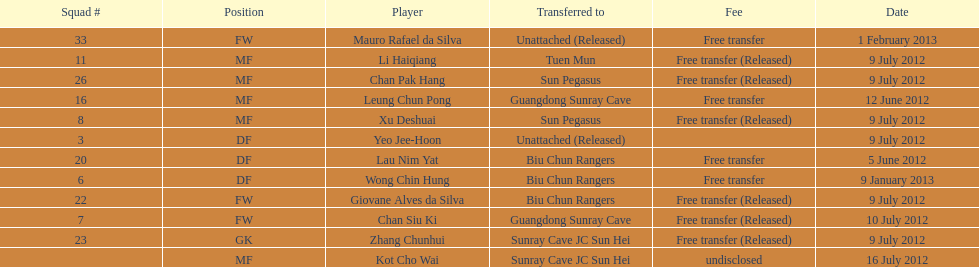Player transferred immediately before mauro rafael da silva Wong Chin Hung. Could you parse the entire table? {'header': ['Squad #', 'Position', 'Player', 'Transferred to', 'Fee', 'Date'], 'rows': [['33', 'FW', 'Mauro Rafael da Silva', 'Unattached (Released)', 'Free transfer', '1 February 2013'], ['11', 'MF', 'Li Haiqiang', 'Tuen Mun', 'Free transfer (Released)', '9 July 2012'], ['26', 'MF', 'Chan Pak Hang', 'Sun Pegasus', 'Free transfer (Released)', '9 July 2012'], ['16', 'MF', 'Leung Chun Pong', 'Guangdong Sunray Cave', 'Free transfer', '12 June 2012'], ['8', 'MF', 'Xu Deshuai', 'Sun Pegasus', 'Free transfer (Released)', '9 July 2012'], ['3', 'DF', 'Yeo Jee-Hoon', 'Unattached (Released)', '', '9 July 2012'], ['20', 'DF', 'Lau Nim Yat', 'Biu Chun Rangers', 'Free transfer', '5 June 2012'], ['6', 'DF', 'Wong Chin Hung', 'Biu Chun Rangers', 'Free transfer', '9 January 2013'], ['22', 'FW', 'Giovane Alves da Silva', 'Biu Chun Rangers', 'Free transfer (Released)', '9 July 2012'], ['7', 'FW', 'Chan Siu Ki', 'Guangdong Sunray Cave', 'Free transfer (Released)', '10 July 2012'], ['23', 'GK', 'Zhang Chunhui', 'Sunray Cave JC Sun Hei', 'Free transfer (Released)', '9 July 2012'], ['', 'MF', 'Kot Cho Wai', 'Sunray Cave JC Sun Hei', 'undisclosed', '16 July 2012']]} 